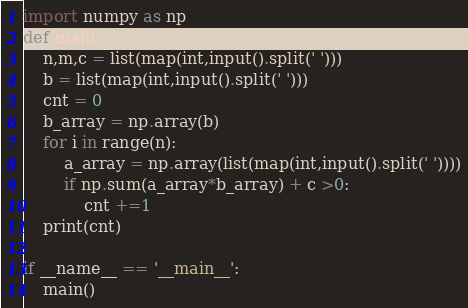<code> <loc_0><loc_0><loc_500><loc_500><_Python_>import numpy as np
def main():
    n,m,c = list(map(int,input().split(' ')))
    b = list(map(int,input().split(' ')))
    cnt = 0
    b_array = np.array(b)
    for i in range(n):
        a_array = np.array(list(map(int,input().split(' '))))
        if np.sum(a_array*b_array) + c >0:
            cnt +=1
    print(cnt)

if __name__ == '__main__':
    main()</code> 